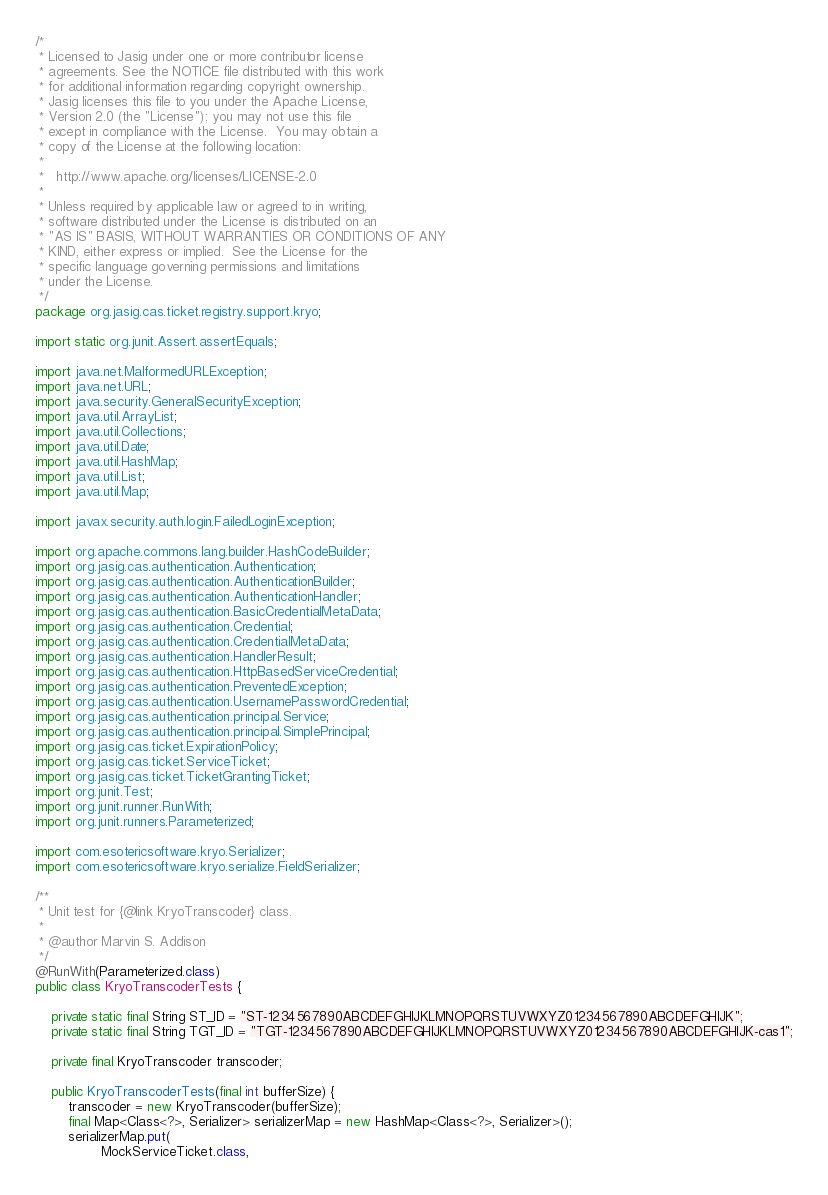Convert code to text. <code><loc_0><loc_0><loc_500><loc_500><_Java_>/*
 * Licensed to Jasig under one or more contributor license
 * agreements. See the NOTICE file distributed with this work
 * for additional information regarding copyright ownership.
 * Jasig licenses this file to you under the Apache License,
 * Version 2.0 (the "License"); you may not use this file
 * except in compliance with the License.  You may obtain a
 * copy of the License at the following location:
 *
 *   http://www.apache.org/licenses/LICENSE-2.0
 *
 * Unless required by applicable law or agreed to in writing,
 * software distributed under the License is distributed on an
 * "AS IS" BASIS, WITHOUT WARRANTIES OR CONDITIONS OF ANY
 * KIND, either express or implied.  See the License for the
 * specific language governing permissions and limitations
 * under the License.
 */
package org.jasig.cas.ticket.registry.support.kryo;

import static org.junit.Assert.assertEquals;

import java.net.MalformedURLException;
import java.net.URL;
import java.security.GeneralSecurityException;
import java.util.ArrayList;
import java.util.Collections;
import java.util.Date;
import java.util.HashMap;
import java.util.List;
import java.util.Map;

import javax.security.auth.login.FailedLoginException;

import org.apache.commons.lang.builder.HashCodeBuilder;
import org.jasig.cas.authentication.Authentication;
import org.jasig.cas.authentication.AuthenticationBuilder;
import org.jasig.cas.authentication.AuthenticationHandler;
import org.jasig.cas.authentication.BasicCredentialMetaData;
import org.jasig.cas.authentication.Credential;
import org.jasig.cas.authentication.CredentialMetaData;
import org.jasig.cas.authentication.HandlerResult;
import org.jasig.cas.authentication.HttpBasedServiceCredential;
import org.jasig.cas.authentication.PreventedException;
import org.jasig.cas.authentication.UsernamePasswordCredential;
import org.jasig.cas.authentication.principal.Service;
import org.jasig.cas.authentication.principal.SimplePrincipal;
import org.jasig.cas.ticket.ExpirationPolicy;
import org.jasig.cas.ticket.ServiceTicket;
import org.jasig.cas.ticket.TicketGrantingTicket;
import org.junit.Test;
import org.junit.runner.RunWith;
import org.junit.runners.Parameterized;

import com.esotericsoftware.kryo.Serializer;
import com.esotericsoftware.kryo.serialize.FieldSerializer;

/**
 * Unit test for {@link KryoTranscoder} class.
 *
 * @author Marvin S. Addison
 */
@RunWith(Parameterized.class)
public class KryoTranscoderTests {

    private static final String ST_ID = "ST-1234567890ABCDEFGHIJKLMNOPQRSTUVWXYZ01234567890ABCDEFGHIJK";
    private static final String TGT_ID = "TGT-1234567890ABCDEFGHIJKLMNOPQRSTUVWXYZ01234567890ABCDEFGHIJK-cas1";
    
    private final KryoTranscoder transcoder;

    public KryoTranscoderTests(final int bufferSize) {
        transcoder = new KryoTranscoder(bufferSize);
        final Map<Class<?>, Serializer> serializerMap = new HashMap<Class<?>, Serializer>();
        serializerMap.put(
                MockServiceTicket.class,</code> 